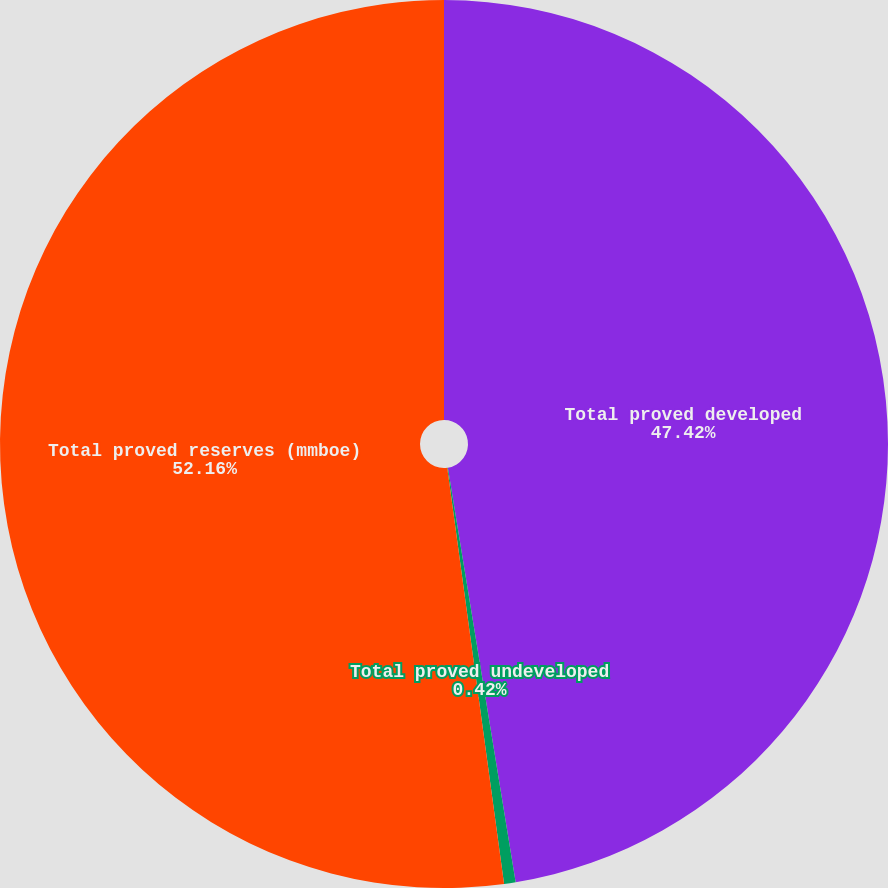Convert chart to OTSL. <chart><loc_0><loc_0><loc_500><loc_500><pie_chart><fcel>Total proved developed<fcel>Total proved undeveloped<fcel>Total proved reserves (mmboe)<nl><fcel>47.42%<fcel>0.42%<fcel>52.16%<nl></chart> 